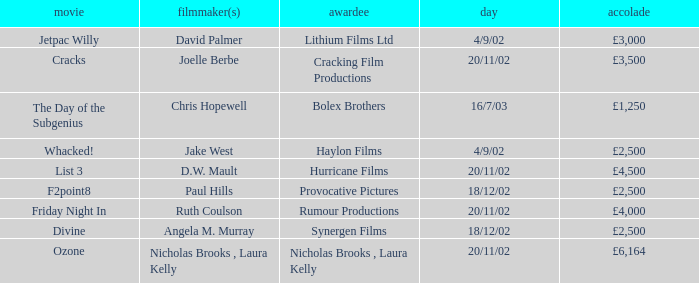Who directed a film for Cracking Film Productions? Joelle Berbe. 